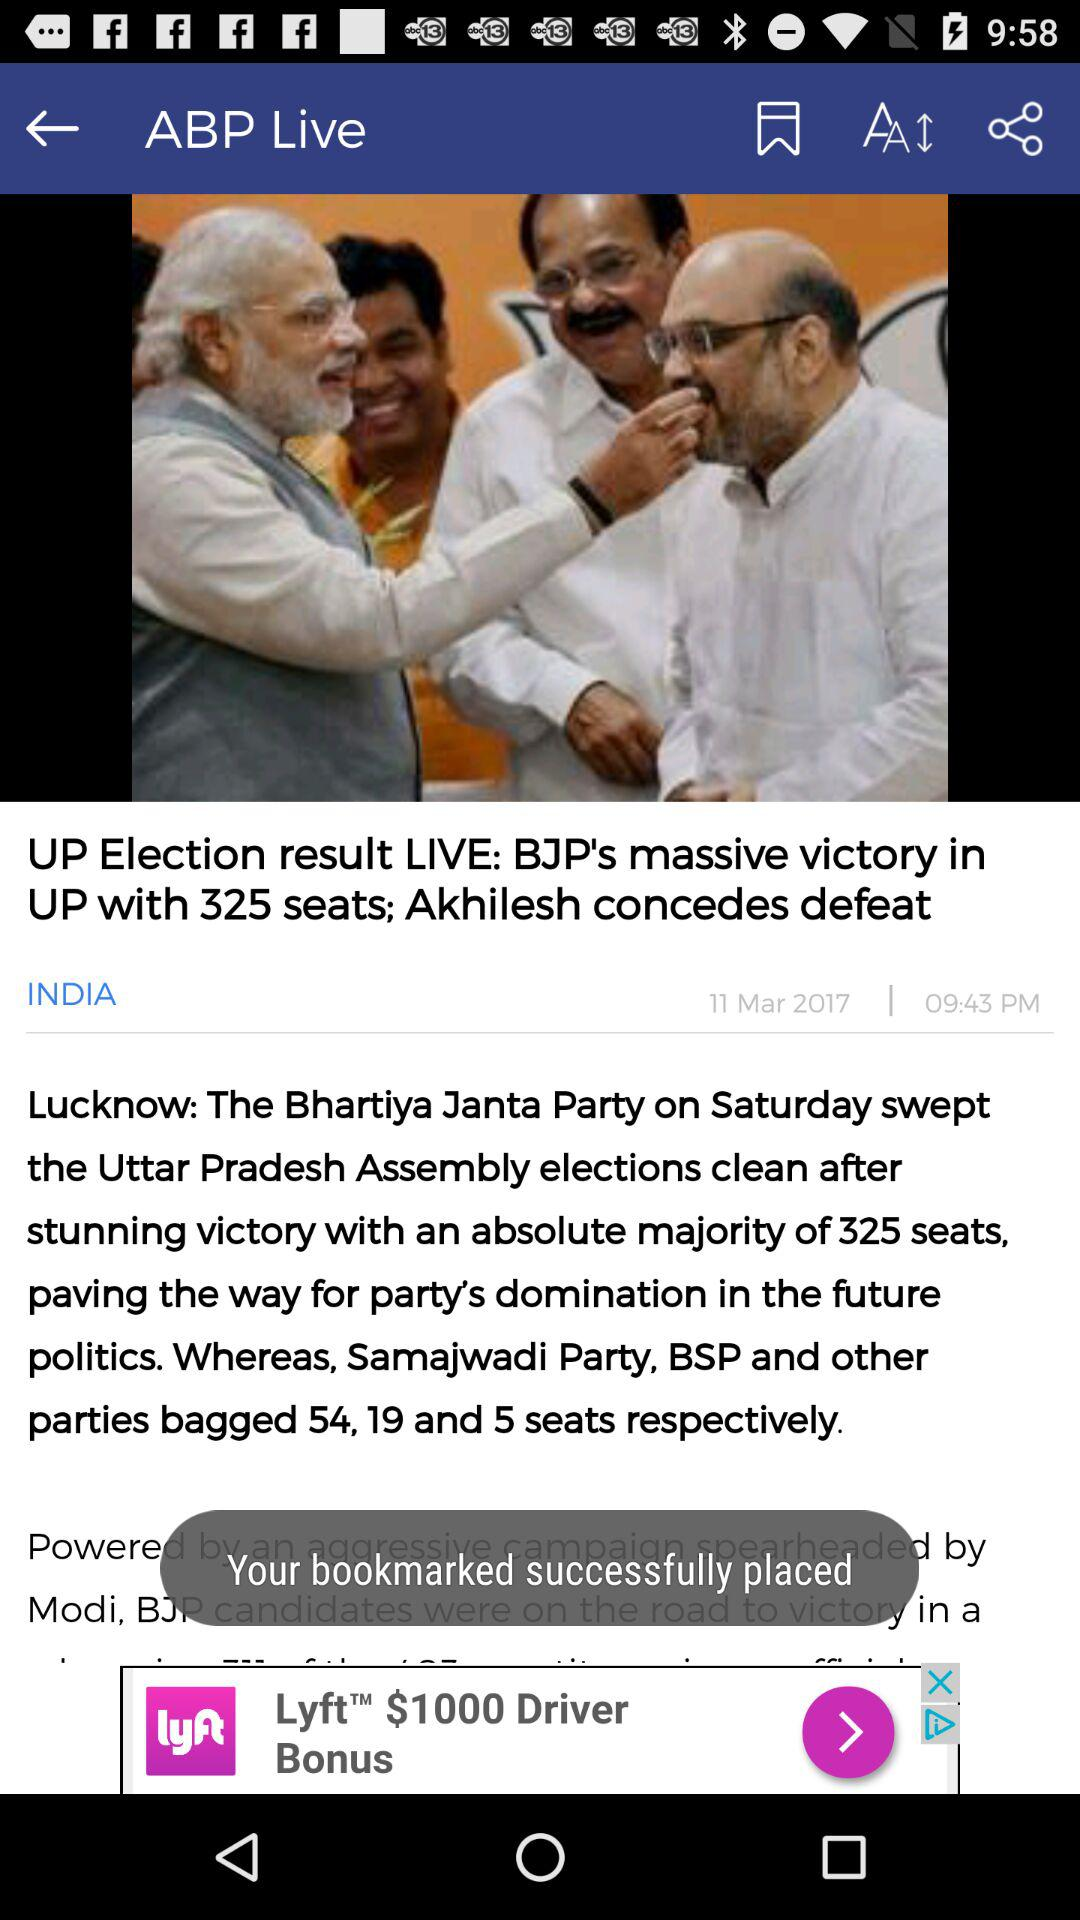How many seats did the BJP get in the election in UP? The BJP got 325 seats in the election in UP. 